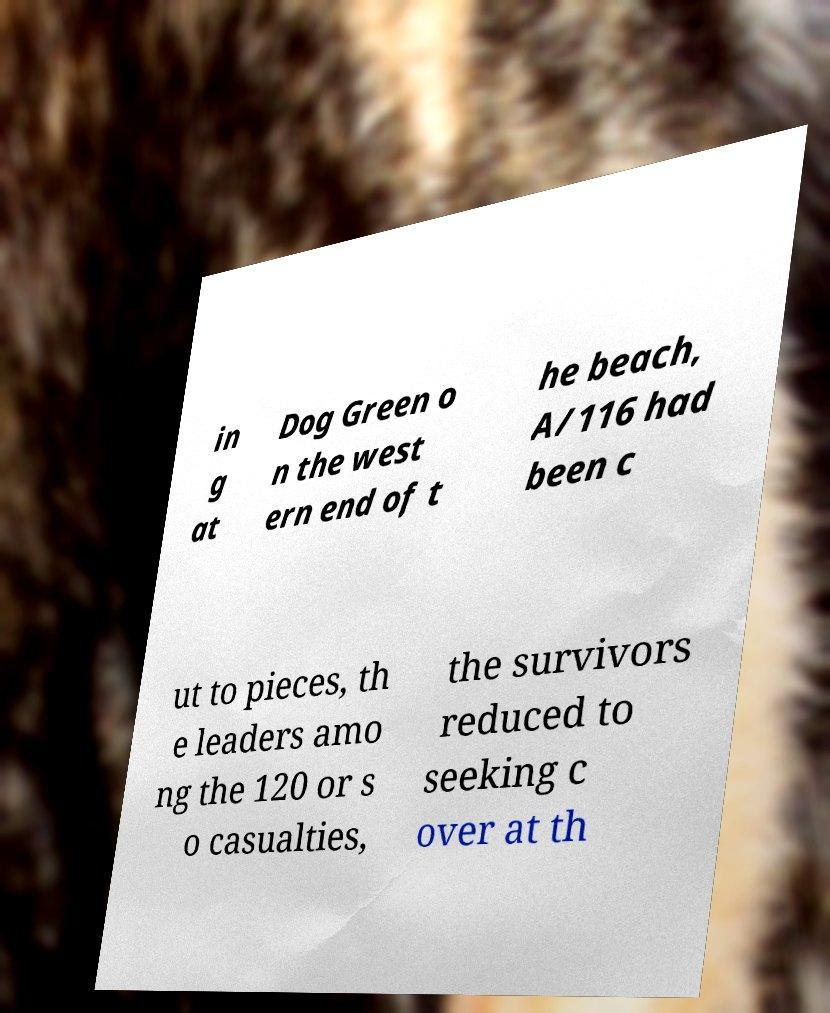I need the written content from this picture converted into text. Can you do that? in g at Dog Green o n the west ern end of t he beach, A/116 had been c ut to pieces, th e leaders amo ng the 120 or s o casualties, the survivors reduced to seeking c over at th 